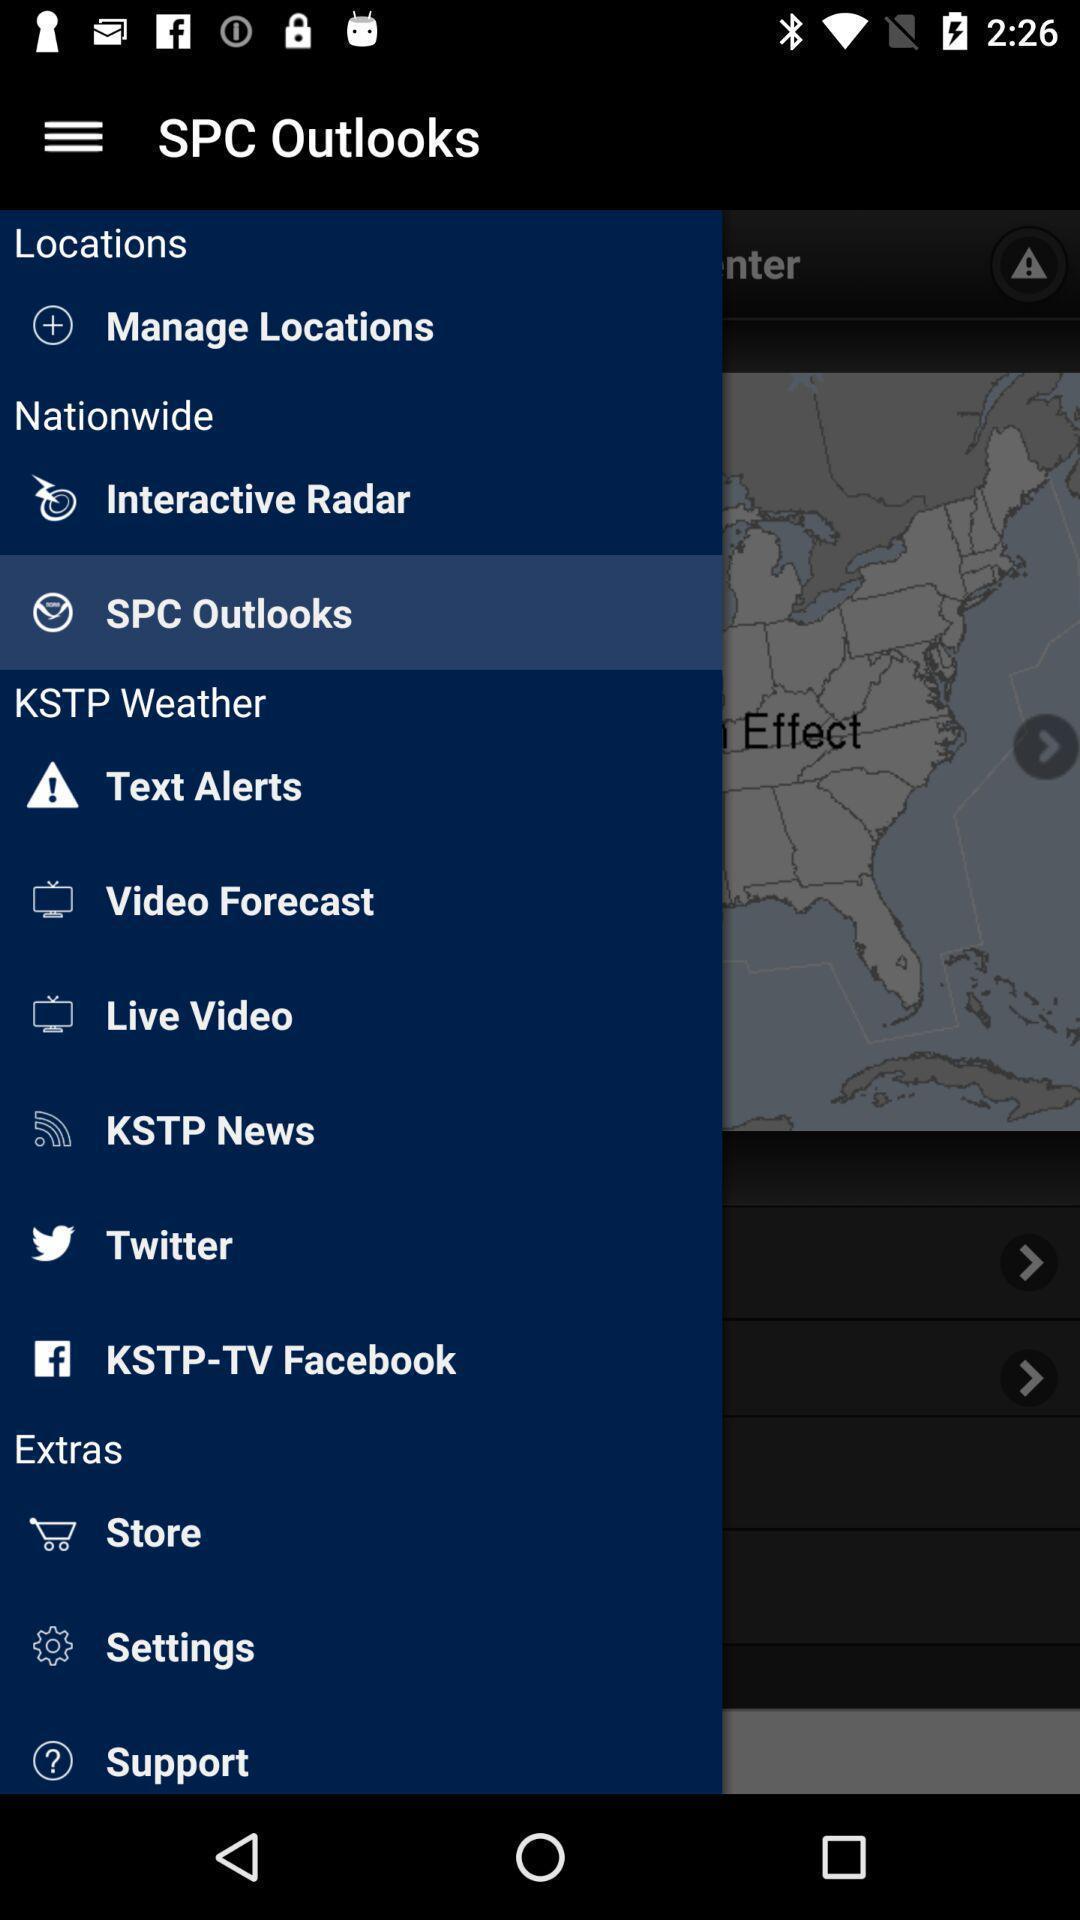Describe the visual elements of this screenshot. Screen shows about an outlook. 